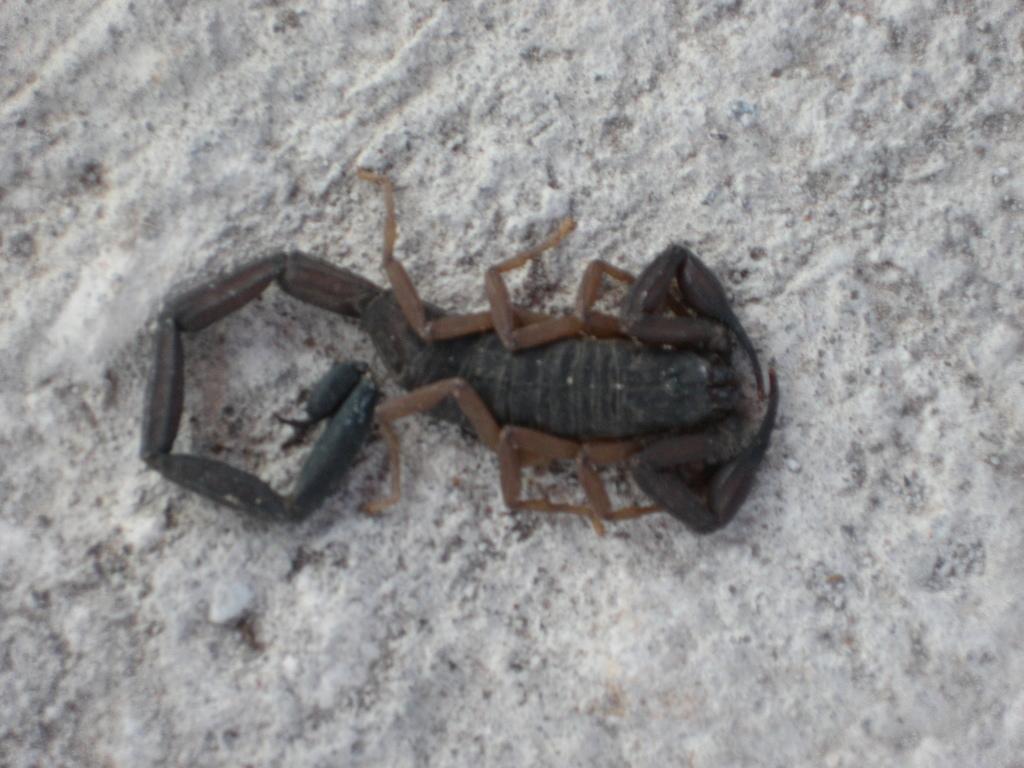Could you give a brief overview of what you see in this image? In this image I can see the scorpion on a white color surface. 